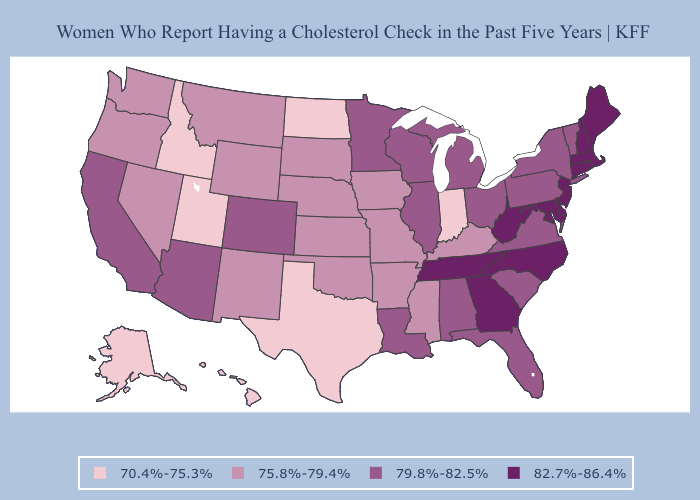Does Iowa have the lowest value in the USA?
Write a very short answer. No. Among the states that border Montana , does North Dakota have the highest value?
Answer briefly. No. Name the states that have a value in the range 70.4%-75.3%?
Answer briefly. Alaska, Hawaii, Idaho, Indiana, North Dakota, Texas, Utah. Does Connecticut have the lowest value in the Northeast?
Concise answer only. No. Does Alaska have a higher value than Louisiana?
Short answer required. No. Name the states that have a value in the range 75.8%-79.4%?
Concise answer only. Arkansas, Iowa, Kansas, Kentucky, Mississippi, Missouri, Montana, Nebraska, Nevada, New Mexico, Oklahoma, Oregon, South Dakota, Washington, Wyoming. What is the value of Louisiana?
Short answer required. 79.8%-82.5%. Does Oklahoma have the same value as Georgia?
Write a very short answer. No. Which states hav the highest value in the MidWest?
Short answer required. Illinois, Michigan, Minnesota, Ohio, Wisconsin. Name the states that have a value in the range 75.8%-79.4%?
Quick response, please. Arkansas, Iowa, Kansas, Kentucky, Mississippi, Missouri, Montana, Nebraska, Nevada, New Mexico, Oklahoma, Oregon, South Dakota, Washington, Wyoming. Does Michigan have the lowest value in the MidWest?
Concise answer only. No. Among the states that border Arizona , which have the highest value?
Keep it brief. California, Colorado. Name the states that have a value in the range 79.8%-82.5%?
Keep it brief. Alabama, Arizona, California, Colorado, Florida, Illinois, Louisiana, Michigan, Minnesota, New York, Ohio, Pennsylvania, South Carolina, Vermont, Virginia, Wisconsin. What is the value of South Carolina?
Be succinct. 79.8%-82.5%. Name the states that have a value in the range 79.8%-82.5%?
Concise answer only. Alabama, Arizona, California, Colorado, Florida, Illinois, Louisiana, Michigan, Minnesota, New York, Ohio, Pennsylvania, South Carolina, Vermont, Virginia, Wisconsin. 